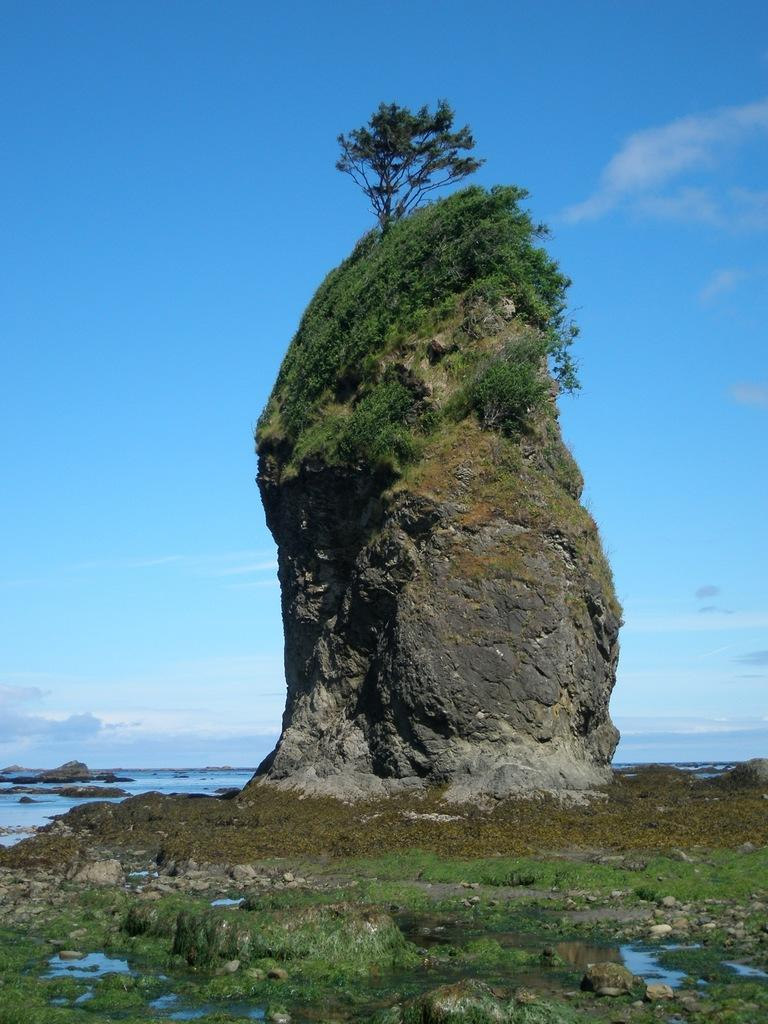What is the primary element in the image? There is water in the image. What other objects can be seen in the image? There are stones, a rock, a tree on the rock, and plants in the image. What is visible in the background of the image? The sky is visible in the background of the image. How many snakes are slithering around the tree on the rock in the image? There are no snakes present in the image. What stage of development is the quiet area in the image? The image does not depict a development stage or a quiet area; it features water, stones, a rock, a tree on the rock, plants, and the sky. 